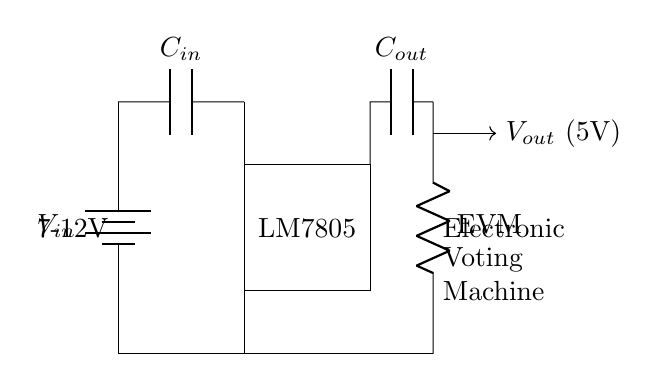What is the input voltage range for this circuit? The voltage range at the input is specified as 7-12 volts, indicated next to the battery symbol in the diagram.
Answer: 7-12 volts What type of voltage regulator is used in this circuit? The circuit uses the LM7805 voltage regulator, which is displayed within the rectangle in the circuit diagram.
Answer: LM7805 What is the purpose of the output capacitor? The output capacitor is used to stabilize the output voltage and filter any noise produced by the regulator. It is connected at the output side of the LM7805 and is labeled in the diagram.
Answer: Stabilization and filtering What is the output voltage provided by this circuit? The circuit is designed to output a voltage of 5 volts, as indicated next to the output arrow leading from the power supply to the load.
Answer: 5 volts What load is being powered by this voltage regulator? The load being powered is an electronic voting machine, as specified by the labels on the right side of the circuit diagram.
Answer: Electronic voting machine How does the input capacitor contribute to the circuit's performance? The input capacitor smooths the input voltage and helps reduce voltage fluctuations, ensuring stable operation of the voltage regulator. It connects from the input source to the regulator, as shown in the circuit.
Answer: Smoothing input voltage 